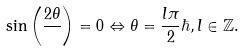Convert formula to latex. <formula><loc_0><loc_0><loc_500><loc_500>\sin \left ( \frac { 2 \theta } { } \right ) = 0 \Leftrightarrow \theta = \frac { l \pi } { 2 } \hbar { , } \, l \in \mathbb { Z } .</formula> 